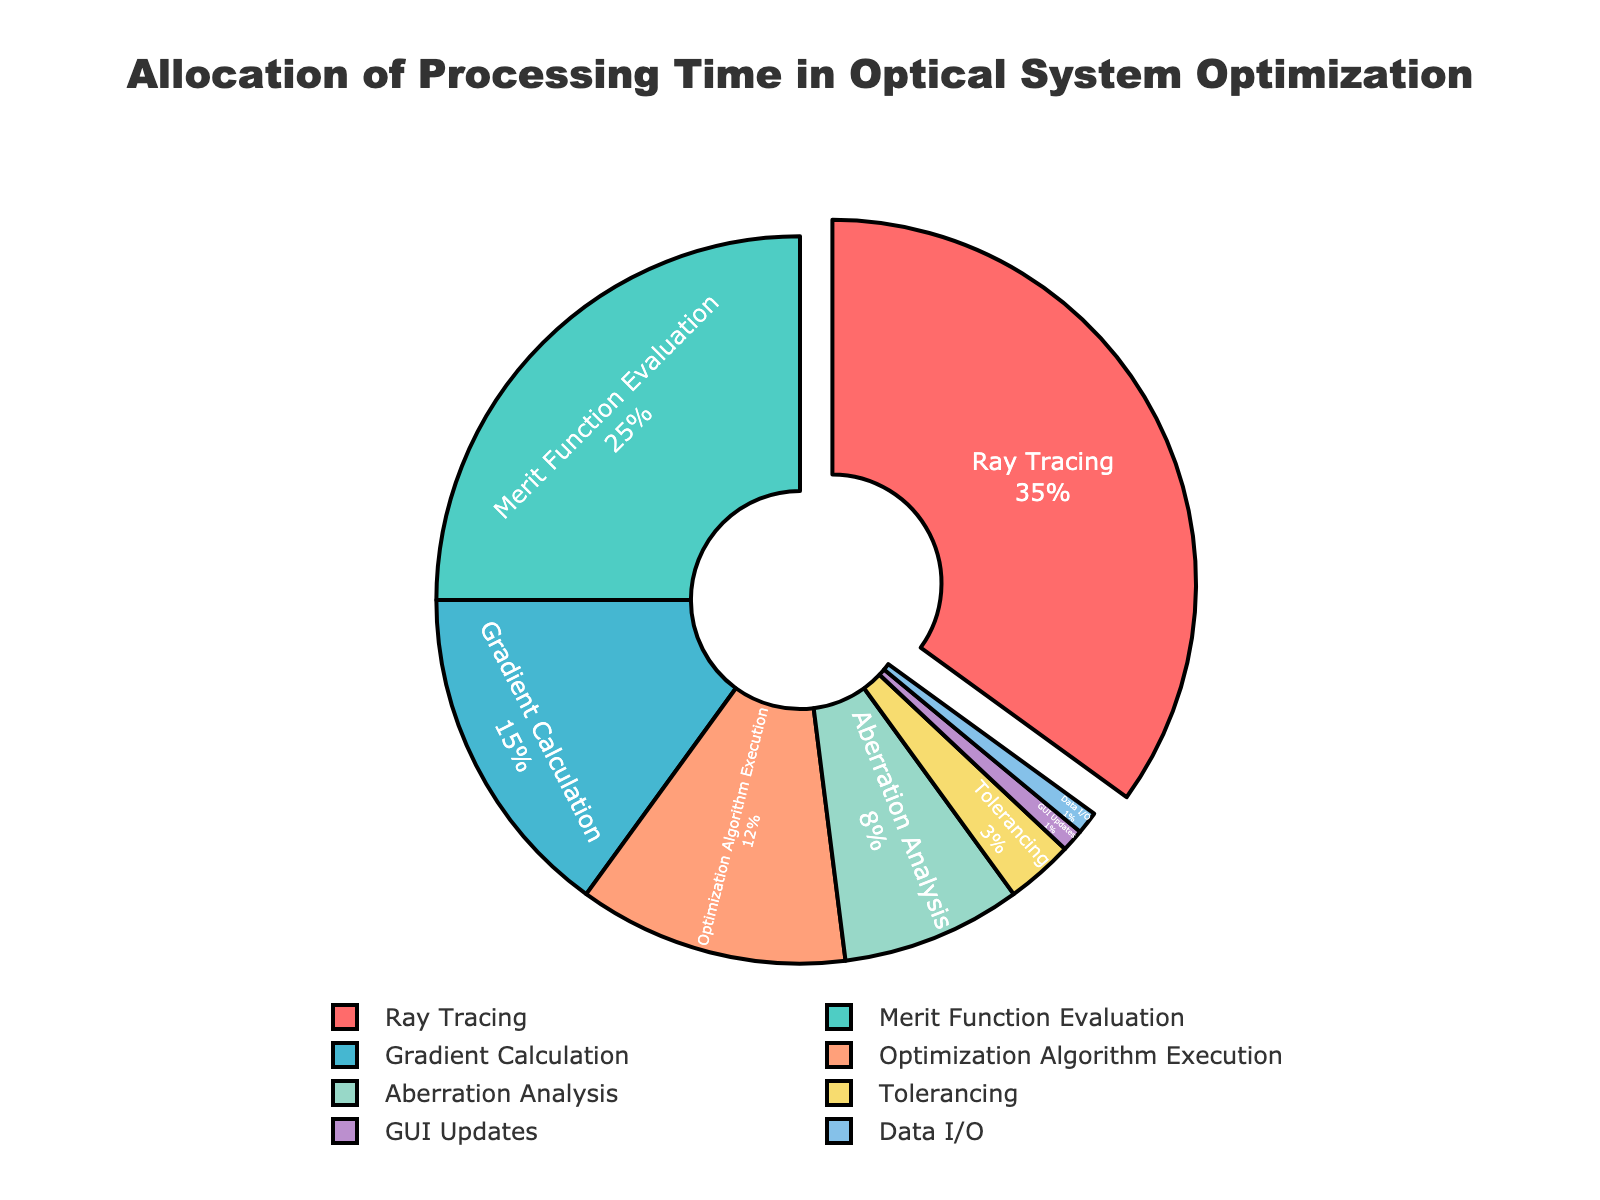Which stage takes up the largest portion of processing time? The figure highlights the largest portion by pulling out the segment for Ray Tracing.
Answer: Ray Tracing Which two stages combined take up more than 50% of the processing time? Adding the percentages for Ray Tracing (35%) and Merit Function Evaluation (25%) gives 60%, which is more than half.
Answer: Ray Tracing and Merit Function Evaluation Which stage has the smallest allocation of processing time? The legend shows GUI Updates and Data I/O each occupy 1%, the smallest portions.
Answer: GUI Updates and Data I/O What is the total processing time allocated to Gradient Calculation and Aberration Analysis combined? Adding the percentages for Gradient Calculation (15%) and Aberration Analysis (8%) gives 23%.
Answer: 23% How does the processing time of Merit Function Evaluation compare to that of Aberration Analysis? Merit Function Evaluation takes 25% and Aberration Analysis takes 8%, so Merit Function Evaluation is larger.
Answer: Merit Function Evaluation is larger What is the difference in processing time between Optimization Algorithm Execution and Tolerancing? Subtracting Tolerancing's 3% from Optimization Algorithm Execution's 12% gives 9%.
Answer: 9% What percentage of processing time is allocated to stages other than Ray Tracing? Subtracting Ray Tracing's 35% from 100% gives 65%.
Answer: 65% How much more processing time is spent on Gradient Calculation compared to GUI Updates? Subtracting GUI Updates' 1% from Gradient Calculation's 15% gives 14%.
Answer: 14% What is the sum of the processing times allocated to stages that have less than 5% allocation individually? Adding Tolerancing (3%), GUI Updates (1%), and Data I/O (1%) results in 5%.
Answer: 5% Which stage is allocated slightly more processing time, Aberration Analysis or Optimization Algorithm Execution? Looking at the percentages: Aberration Analysis is 8% and Optimization Algorithm Execution is 12%.
Answer: Optimization Algorithm Execution 